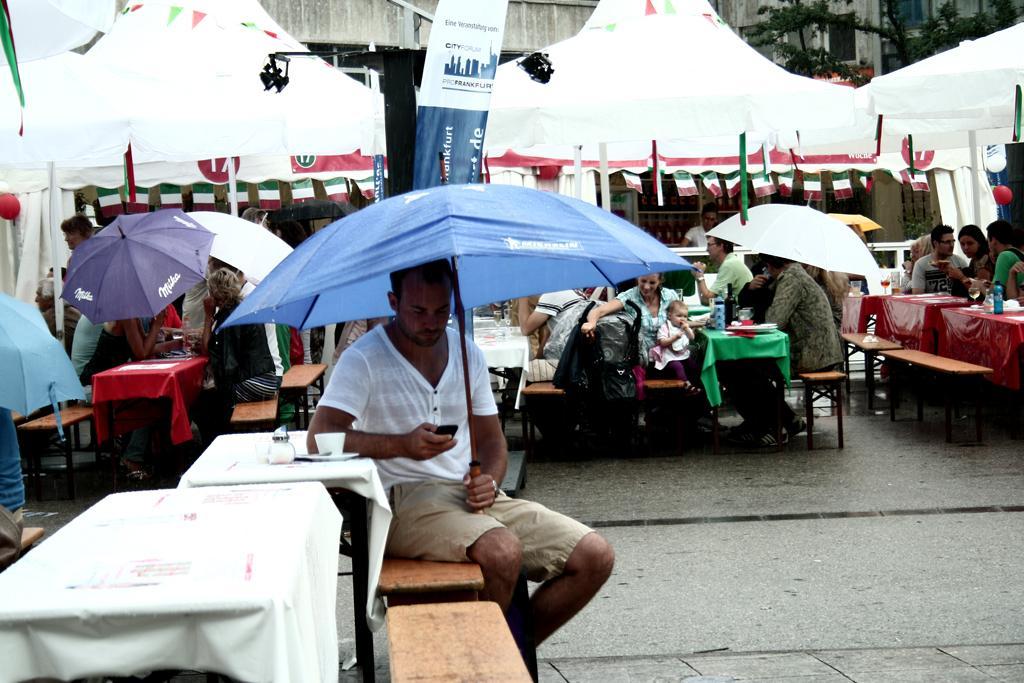In one or two sentences, can you explain what this image depicts? In this image i can see man sitting on the bench and holding an umbrella and a mobile beside a man there is a cup,a table at the back ground i can see a group of people sitting on the table there is a tent on the background and a banner. 